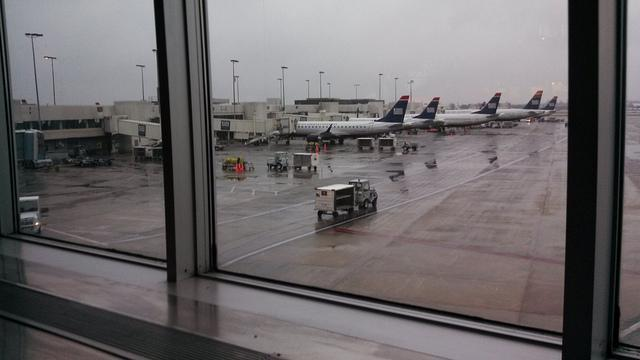What would be the most likely cause of a travel delay for this airport?

Choices:
A) rain
B) snow
C) wind
D) clouds clouds 